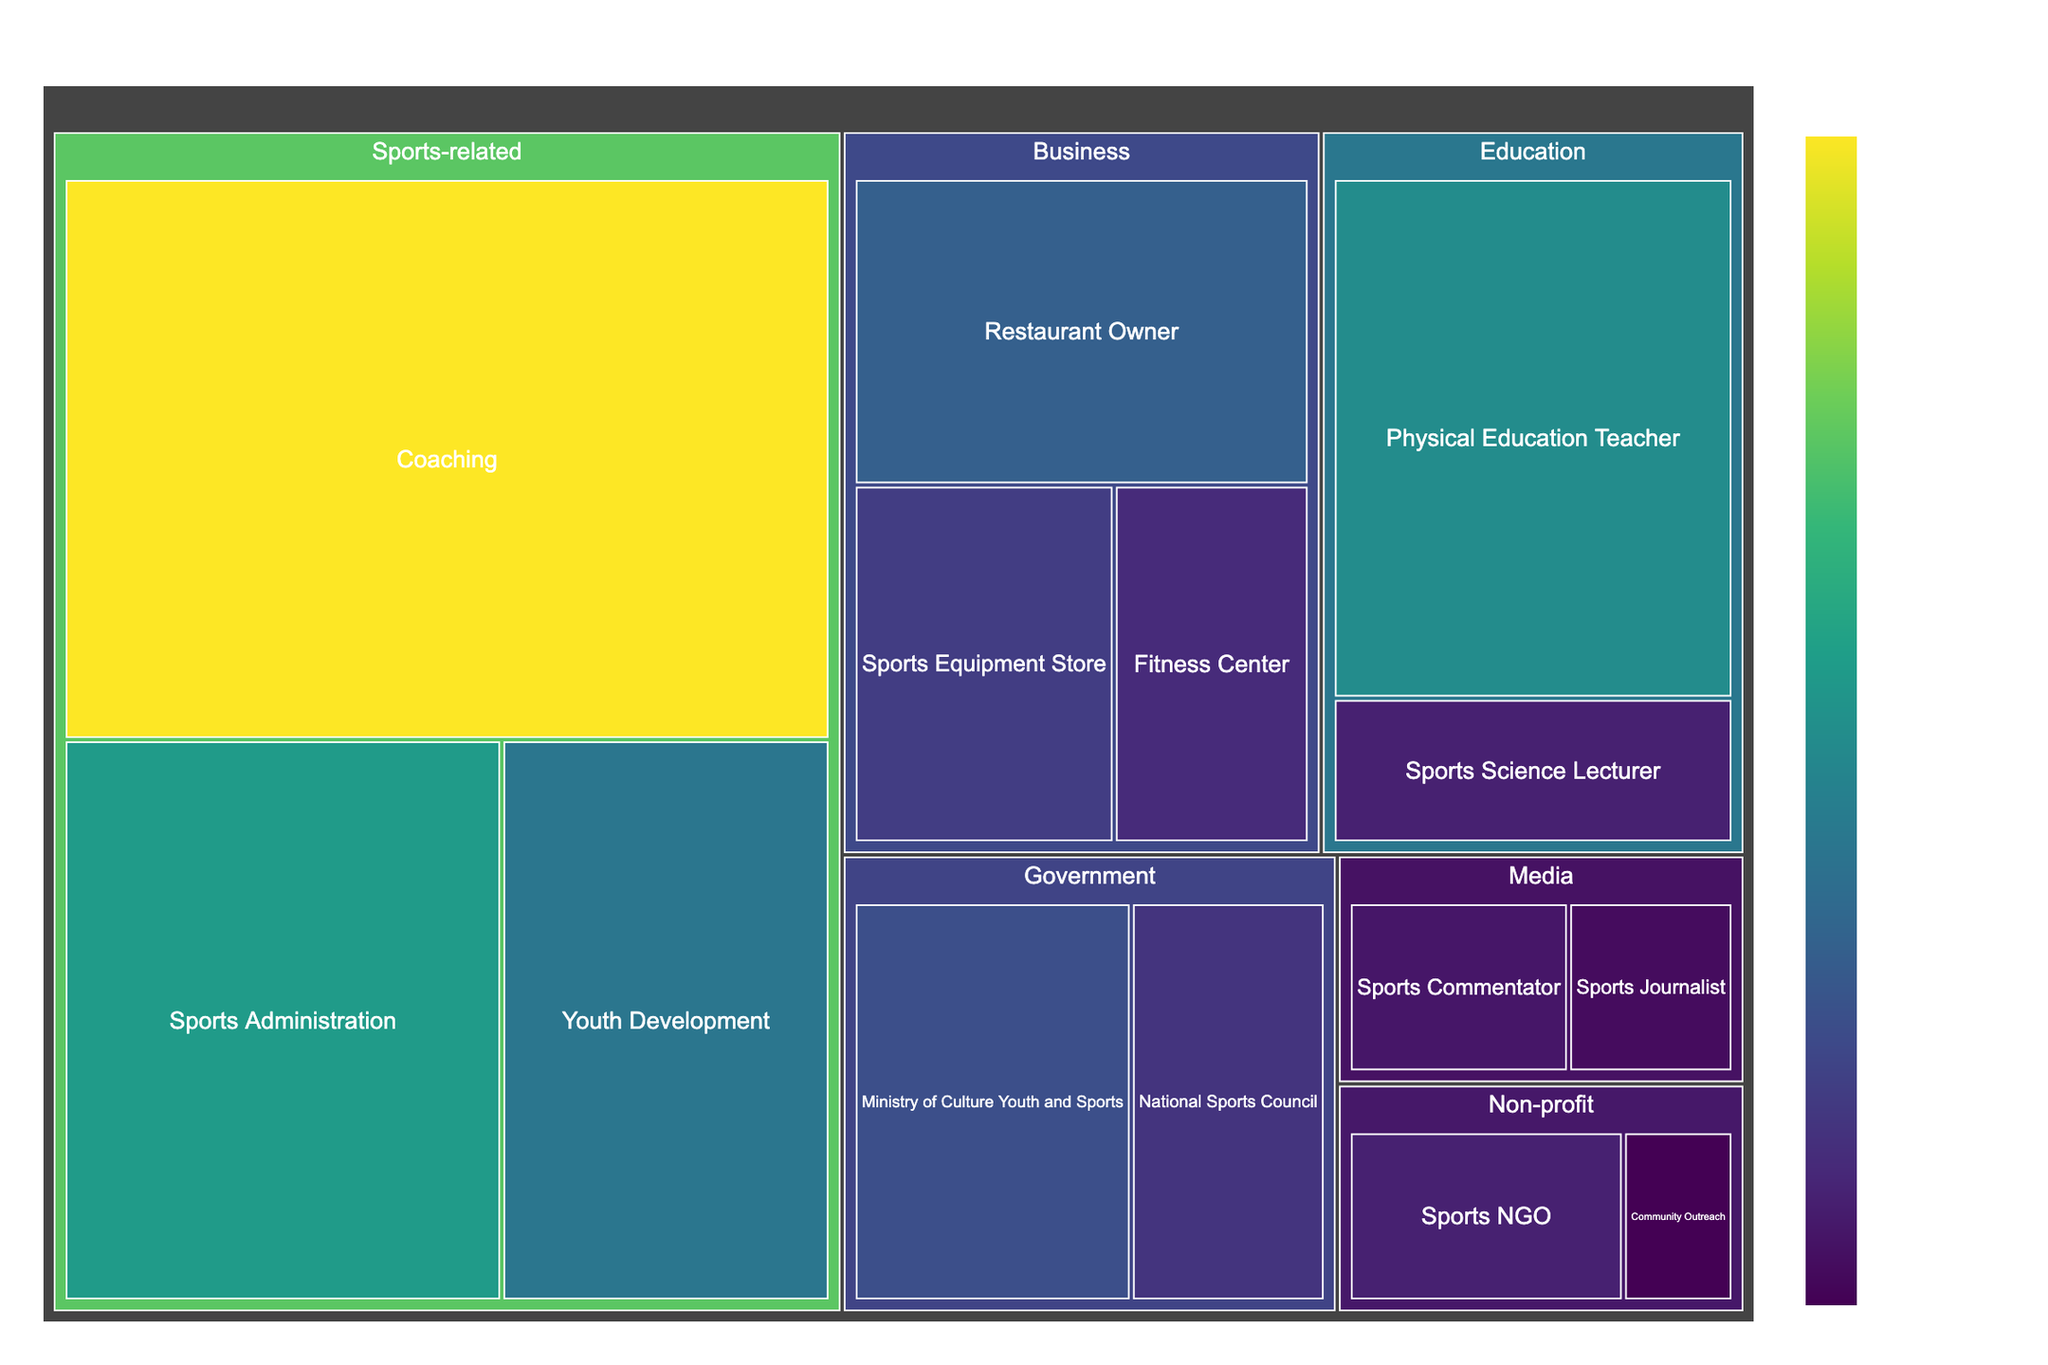What is the title of the figure? The title is usually located at the top of the figure and provides a summary of what the figure represents.
Answer: Distribution of Retired Bruneian Athletes' Post-Career Occupations How many athletes have taken up coaching as a post-career occupation? Coaching falls under the Sports-related category. We locate the coaching tile and read its value.
Answer: 35 What is the total number of athletes in the Government category? First, find the values for the subcategories under the Government category (Ministry of Culture Youth and Sports and National Sports Council). Add these values together (10 + 7).
Answer: 17 Which subcategory under the Business category has the least number of athletes? Compare the values for the subcategories in the Business category (Restaurant Owner, Sports Equipment Store, and Fitness Center). Identify the smallest value.
Answer: Fitness Center What is the combined number of athletes in Media and Non-profit categories? Find the values for each subcategory under Media (Sports Commentator and Sports Journalist) and Non-profit (Sports NGO and Community Outreach). Add these values together (4 + 3 + 5 + 2).
Answer: 14 Which category has the highest number of athletes transitioning into post-career occupations? Compare the summed values of each main category (Sports-related, Business, Government, Education, Media, Non-profit). Identify the category with the highest total. Calculations: Sports-related (35 + 20 + 15 = 70), Business (12 + 8 + 6 = 26), Government (10 + 7 = 17), Education (18 + 5 = 23), Media (4 + 3 = 7), Non-profit (5 + 2 = 7).
Answer: Sports-related What is the difference in the number of athletes between the category with the highest representation and the category with the lowest representation? First, identify the highest and lowest represented categories by their total values. We previously calculated 70 for Sports-related and 7 for both Media and Non-profit. Subtract 7 from 70.
Answer: 63 How does the number of athletes in Youth Development compare to the number of athletes who became Physical Education Teachers? Compare the values for Youth Development under Sports-related (15) and Physical Education Teacher under Education (18).
Answer: 3 fewer in Youth Development 